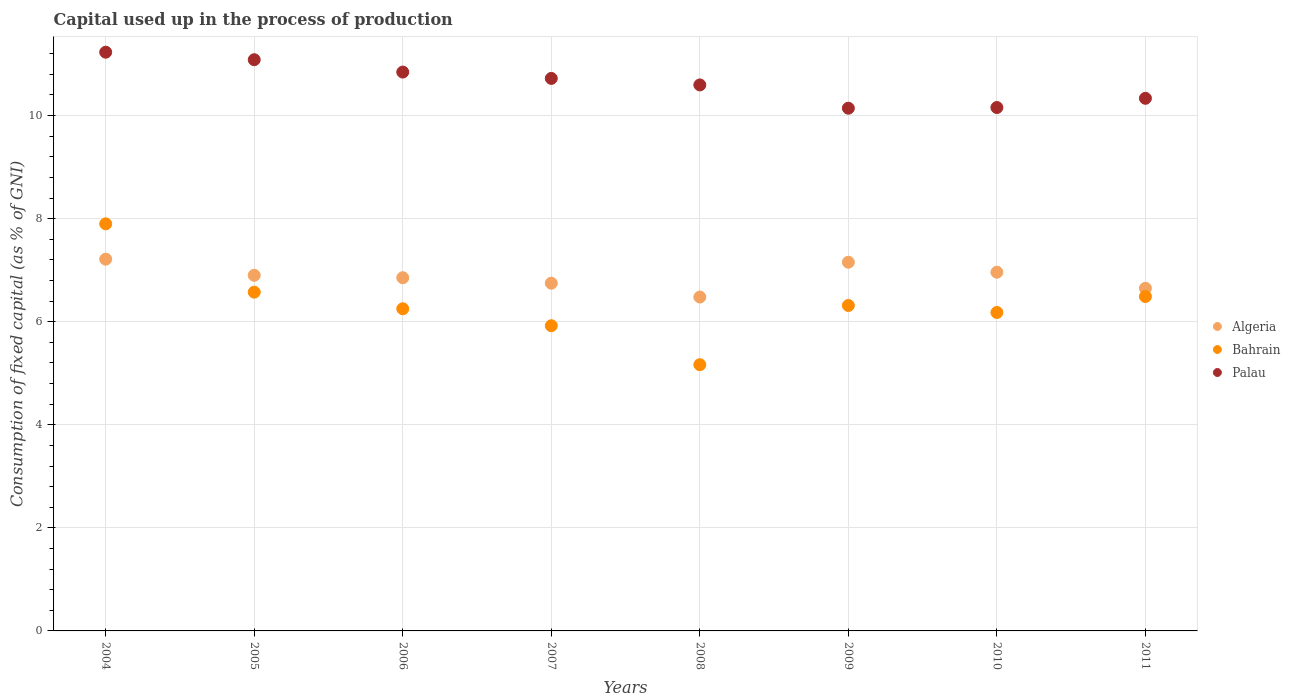What is the capital used up in the process of production in Algeria in 2007?
Give a very brief answer. 6.75. Across all years, what is the maximum capital used up in the process of production in Algeria?
Your answer should be compact. 7.21. Across all years, what is the minimum capital used up in the process of production in Algeria?
Your answer should be compact. 6.48. In which year was the capital used up in the process of production in Algeria minimum?
Provide a short and direct response. 2008. What is the total capital used up in the process of production in Palau in the graph?
Offer a very short reply. 85.11. What is the difference between the capital used up in the process of production in Algeria in 2004 and that in 2011?
Offer a very short reply. 0.56. What is the difference between the capital used up in the process of production in Palau in 2011 and the capital used up in the process of production in Bahrain in 2008?
Your answer should be compact. 5.17. What is the average capital used up in the process of production in Palau per year?
Keep it short and to the point. 10.64. In the year 2007, what is the difference between the capital used up in the process of production in Palau and capital used up in the process of production in Bahrain?
Offer a very short reply. 4.8. In how many years, is the capital used up in the process of production in Algeria greater than 6.8 %?
Provide a short and direct response. 5. What is the ratio of the capital used up in the process of production in Palau in 2006 to that in 2009?
Your answer should be compact. 1.07. Is the capital used up in the process of production in Algeria in 2008 less than that in 2011?
Offer a terse response. Yes. What is the difference between the highest and the second highest capital used up in the process of production in Palau?
Provide a short and direct response. 0.15. What is the difference between the highest and the lowest capital used up in the process of production in Palau?
Make the answer very short. 1.09. In how many years, is the capital used up in the process of production in Algeria greater than the average capital used up in the process of production in Algeria taken over all years?
Offer a terse response. 4. Is it the case that in every year, the sum of the capital used up in the process of production in Bahrain and capital used up in the process of production in Algeria  is greater than the capital used up in the process of production in Palau?
Your answer should be very brief. Yes. Does the capital used up in the process of production in Algeria monotonically increase over the years?
Provide a short and direct response. No. Is the capital used up in the process of production in Palau strictly greater than the capital used up in the process of production in Bahrain over the years?
Offer a terse response. Yes. What is the difference between two consecutive major ticks on the Y-axis?
Give a very brief answer. 2. Are the values on the major ticks of Y-axis written in scientific E-notation?
Offer a very short reply. No. Does the graph contain grids?
Provide a succinct answer. Yes. How many legend labels are there?
Make the answer very short. 3. How are the legend labels stacked?
Provide a succinct answer. Vertical. What is the title of the graph?
Offer a very short reply. Capital used up in the process of production. What is the label or title of the X-axis?
Your answer should be very brief. Years. What is the label or title of the Y-axis?
Make the answer very short. Consumption of fixed capital (as % of GNI). What is the Consumption of fixed capital (as % of GNI) in Algeria in 2004?
Give a very brief answer. 7.21. What is the Consumption of fixed capital (as % of GNI) in Bahrain in 2004?
Your answer should be compact. 7.9. What is the Consumption of fixed capital (as % of GNI) of Palau in 2004?
Ensure brevity in your answer.  11.23. What is the Consumption of fixed capital (as % of GNI) in Algeria in 2005?
Ensure brevity in your answer.  6.9. What is the Consumption of fixed capital (as % of GNI) of Bahrain in 2005?
Make the answer very short. 6.57. What is the Consumption of fixed capital (as % of GNI) in Palau in 2005?
Offer a terse response. 11.08. What is the Consumption of fixed capital (as % of GNI) of Algeria in 2006?
Offer a very short reply. 6.85. What is the Consumption of fixed capital (as % of GNI) in Bahrain in 2006?
Your answer should be very brief. 6.25. What is the Consumption of fixed capital (as % of GNI) of Palau in 2006?
Make the answer very short. 10.84. What is the Consumption of fixed capital (as % of GNI) in Algeria in 2007?
Your response must be concise. 6.75. What is the Consumption of fixed capital (as % of GNI) of Bahrain in 2007?
Offer a very short reply. 5.92. What is the Consumption of fixed capital (as % of GNI) of Palau in 2007?
Your answer should be compact. 10.72. What is the Consumption of fixed capital (as % of GNI) in Algeria in 2008?
Ensure brevity in your answer.  6.48. What is the Consumption of fixed capital (as % of GNI) in Bahrain in 2008?
Offer a terse response. 5.17. What is the Consumption of fixed capital (as % of GNI) in Palau in 2008?
Offer a terse response. 10.6. What is the Consumption of fixed capital (as % of GNI) of Algeria in 2009?
Make the answer very short. 7.15. What is the Consumption of fixed capital (as % of GNI) of Bahrain in 2009?
Give a very brief answer. 6.32. What is the Consumption of fixed capital (as % of GNI) in Palau in 2009?
Your answer should be very brief. 10.14. What is the Consumption of fixed capital (as % of GNI) of Algeria in 2010?
Your response must be concise. 6.96. What is the Consumption of fixed capital (as % of GNI) of Bahrain in 2010?
Your response must be concise. 6.18. What is the Consumption of fixed capital (as % of GNI) of Palau in 2010?
Your answer should be very brief. 10.16. What is the Consumption of fixed capital (as % of GNI) of Algeria in 2011?
Ensure brevity in your answer.  6.65. What is the Consumption of fixed capital (as % of GNI) in Bahrain in 2011?
Your response must be concise. 6.49. What is the Consumption of fixed capital (as % of GNI) of Palau in 2011?
Offer a terse response. 10.34. Across all years, what is the maximum Consumption of fixed capital (as % of GNI) in Algeria?
Your answer should be compact. 7.21. Across all years, what is the maximum Consumption of fixed capital (as % of GNI) in Bahrain?
Offer a very short reply. 7.9. Across all years, what is the maximum Consumption of fixed capital (as % of GNI) in Palau?
Give a very brief answer. 11.23. Across all years, what is the minimum Consumption of fixed capital (as % of GNI) of Algeria?
Ensure brevity in your answer.  6.48. Across all years, what is the minimum Consumption of fixed capital (as % of GNI) of Bahrain?
Your answer should be very brief. 5.17. Across all years, what is the minimum Consumption of fixed capital (as % of GNI) of Palau?
Your answer should be compact. 10.14. What is the total Consumption of fixed capital (as % of GNI) in Algeria in the graph?
Your response must be concise. 54.96. What is the total Consumption of fixed capital (as % of GNI) of Bahrain in the graph?
Your answer should be very brief. 50.8. What is the total Consumption of fixed capital (as % of GNI) in Palau in the graph?
Offer a terse response. 85.11. What is the difference between the Consumption of fixed capital (as % of GNI) of Algeria in 2004 and that in 2005?
Your answer should be compact. 0.31. What is the difference between the Consumption of fixed capital (as % of GNI) in Bahrain in 2004 and that in 2005?
Your answer should be compact. 1.33. What is the difference between the Consumption of fixed capital (as % of GNI) of Palau in 2004 and that in 2005?
Your answer should be very brief. 0.15. What is the difference between the Consumption of fixed capital (as % of GNI) in Algeria in 2004 and that in 2006?
Keep it short and to the point. 0.36. What is the difference between the Consumption of fixed capital (as % of GNI) of Bahrain in 2004 and that in 2006?
Offer a very short reply. 1.65. What is the difference between the Consumption of fixed capital (as % of GNI) in Palau in 2004 and that in 2006?
Provide a succinct answer. 0.39. What is the difference between the Consumption of fixed capital (as % of GNI) of Algeria in 2004 and that in 2007?
Ensure brevity in your answer.  0.47. What is the difference between the Consumption of fixed capital (as % of GNI) in Bahrain in 2004 and that in 2007?
Your response must be concise. 1.98. What is the difference between the Consumption of fixed capital (as % of GNI) in Palau in 2004 and that in 2007?
Make the answer very short. 0.51. What is the difference between the Consumption of fixed capital (as % of GNI) in Algeria in 2004 and that in 2008?
Ensure brevity in your answer.  0.73. What is the difference between the Consumption of fixed capital (as % of GNI) in Bahrain in 2004 and that in 2008?
Make the answer very short. 2.73. What is the difference between the Consumption of fixed capital (as % of GNI) in Palau in 2004 and that in 2008?
Ensure brevity in your answer.  0.64. What is the difference between the Consumption of fixed capital (as % of GNI) in Algeria in 2004 and that in 2009?
Make the answer very short. 0.06. What is the difference between the Consumption of fixed capital (as % of GNI) of Bahrain in 2004 and that in 2009?
Offer a terse response. 1.58. What is the difference between the Consumption of fixed capital (as % of GNI) in Palau in 2004 and that in 2009?
Your answer should be very brief. 1.09. What is the difference between the Consumption of fixed capital (as % of GNI) in Algeria in 2004 and that in 2010?
Make the answer very short. 0.25. What is the difference between the Consumption of fixed capital (as % of GNI) of Bahrain in 2004 and that in 2010?
Your answer should be very brief. 1.72. What is the difference between the Consumption of fixed capital (as % of GNI) of Palau in 2004 and that in 2010?
Keep it short and to the point. 1.07. What is the difference between the Consumption of fixed capital (as % of GNI) of Algeria in 2004 and that in 2011?
Your answer should be very brief. 0.56. What is the difference between the Consumption of fixed capital (as % of GNI) in Bahrain in 2004 and that in 2011?
Your answer should be very brief. 1.41. What is the difference between the Consumption of fixed capital (as % of GNI) in Palau in 2004 and that in 2011?
Your answer should be very brief. 0.89. What is the difference between the Consumption of fixed capital (as % of GNI) of Algeria in 2005 and that in 2006?
Provide a succinct answer. 0.05. What is the difference between the Consumption of fixed capital (as % of GNI) of Bahrain in 2005 and that in 2006?
Provide a short and direct response. 0.32. What is the difference between the Consumption of fixed capital (as % of GNI) in Palau in 2005 and that in 2006?
Offer a very short reply. 0.24. What is the difference between the Consumption of fixed capital (as % of GNI) in Algeria in 2005 and that in 2007?
Your answer should be very brief. 0.15. What is the difference between the Consumption of fixed capital (as % of GNI) in Bahrain in 2005 and that in 2007?
Ensure brevity in your answer.  0.65. What is the difference between the Consumption of fixed capital (as % of GNI) of Palau in 2005 and that in 2007?
Make the answer very short. 0.36. What is the difference between the Consumption of fixed capital (as % of GNI) of Algeria in 2005 and that in 2008?
Your answer should be compact. 0.42. What is the difference between the Consumption of fixed capital (as % of GNI) in Bahrain in 2005 and that in 2008?
Offer a very short reply. 1.41. What is the difference between the Consumption of fixed capital (as % of GNI) in Palau in 2005 and that in 2008?
Your answer should be compact. 0.49. What is the difference between the Consumption of fixed capital (as % of GNI) of Algeria in 2005 and that in 2009?
Offer a terse response. -0.25. What is the difference between the Consumption of fixed capital (as % of GNI) of Bahrain in 2005 and that in 2009?
Your answer should be very brief. 0.26. What is the difference between the Consumption of fixed capital (as % of GNI) of Palau in 2005 and that in 2009?
Offer a terse response. 0.94. What is the difference between the Consumption of fixed capital (as % of GNI) of Algeria in 2005 and that in 2010?
Offer a very short reply. -0.06. What is the difference between the Consumption of fixed capital (as % of GNI) in Bahrain in 2005 and that in 2010?
Provide a short and direct response. 0.39. What is the difference between the Consumption of fixed capital (as % of GNI) of Palau in 2005 and that in 2010?
Ensure brevity in your answer.  0.93. What is the difference between the Consumption of fixed capital (as % of GNI) in Algeria in 2005 and that in 2011?
Provide a succinct answer. 0.25. What is the difference between the Consumption of fixed capital (as % of GNI) in Bahrain in 2005 and that in 2011?
Your answer should be compact. 0.08. What is the difference between the Consumption of fixed capital (as % of GNI) of Palau in 2005 and that in 2011?
Your answer should be very brief. 0.75. What is the difference between the Consumption of fixed capital (as % of GNI) of Algeria in 2006 and that in 2007?
Keep it short and to the point. 0.11. What is the difference between the Consumption of fixed capital (as % of GNI) of Bahrain in 2006 and that in 2007?
Your answer should be compact. 0.33. What is the difference between the Consumption of fixed capital (as % of GNI) in Palau in 2006 and that in 2007?
Ensure brevity in your answer.  0.12. What is the difference between the Consumption of fixed capital (as % of GNI) in Algeria in 2006 and that in 2008?
Your answer should be compact. 0.37. What is the difference between the Consumption of fixed capital (as % of GNI) in Bahrain in 2006 and that in 2008?
Offer a very short reply. 1.09. What is the difference between the Consumption of fixed capital (as % of GNI) in Palau in 2006 and that in 2008?
Your response must be concise. 0.25. What is the difference between the Consumption of fixed capital (as % of GNI) of Algeria in 2006 and that in 2009?
Ensure brevity in your answer.  -0.3. What is the difference between the Consumption of fixed capital (as % of GNI) in Bahrain in 2006 and that in 2009?
Your answer should be compact. -0.06. What is the difference between the Consumption of fixed capital (as % of GNI) in Palau in 2006 and that in 2009?
Provide a short and direct response. 0.7. What is the difference between the Consumption of fixed capital (as % of GNI) of Algeria in 2006 and that in 2010?
Provide a succinct answer. -0.11. What is the difference between the Consumption of fixed capital (as % of GNI) in Bahrain in 2006 and that in 2010?
Keep it short and to the point. 0.07. What is the difference between the Consumption of fixed capital (as % of GNI) of Palau in 2006 and that in 2010?
Your response must be concise. 0.69. What is the difference between the Consumption of fixed capital (as % of GNI) in Algeria in 2006 and that in 2011?
Provide a short and direct response. 0.2. What is the difference between the Consumption of fixed capital (as % of GNI) in Bahrain in 2006 and that in 2011?
Provide a succinct answer. -0.24. What is the difference between the Consumption of fixed capital (as % of GNI) in Palau in 2006 and that in 2011?
Give a very brief answer. 0.51. What is the difference between the Consumption of fixed capital (as % of GNI) of Algeria in 2007 and that in 2008?
Offer a very short reply. 0.27. What is the difference between the Consumption of fixed capital (as % of GNI) in Bahrain in 2007 and that in 2008?
Make the answer very short. 0.76. What is the difference between the Consumption of fixed capital (as % of GNI) of Palau in 2007 and that in 2008?
Your response must be concise. 0.13. What is the difference between the Consumption of fixed capital (as % of GNI) of Algeria in 2007 and that in 2009?
Provide a succinct answer. -0.41. What is the difference between the Consumption of fixed capital (as % of GNI) in Bahrain in 2007 and that in 2009?
Your answer should be very brief. -0.39. What is the difference between the Consumption of fixed capital (as % of GNI) of Palau in 2007 and that in 2009?
Your response must be concise. 0.58. What is the difference between the Consumption of fixed capital (as % of GNI) of Algeria in 2007 and that in 2010?
Your answer should be very brief. -0.21. What is the difference between the Consumption of fixed capital (as % of GNI) of Bahrain in 2007 and that in 2010?
Your answer should be compact. -0.26. What is the difference between the Consumption of fixed capital (as % of GNI) of Palau in 2007 and that in 2010?
Keep it short and to the point. 0.56. What is the difference between the Consumption of fixed capital (as % of GNI) of Algeria in 2007 and that in 2011?
Offer a terse response. 0.1. What is the difference between the Consumption of fixed capital (as % of GNI) in Bahrain in 2007 and that in 2011?
Your answer should be very brief. -0.57. What is the difference between the Consumption of fixed capital (as % of GNI) in Palau in 2007 and that in 2011?
Provide a short and direct response. 0.39. What is the difference between the Consumption of fixed capital (as % of GNI) of Algeria in 2008 and that in 2009?
Your answer should be very brief. -0.68. What is the difference between the Consumption of fixed capital (as % of GNI) in Bahrain in 2008 and that in 2009?
Give a very brief answer. -1.15. What is the difference between the Consumption of fixed capital (as % of GNI) in Palau in 2008 and that in 2009?
Your answer should be compact. 0.45. What is the difference between the Consumption of fixed capital (as % of GNI) in Algeria in 2008 and that in 2010?
Make the answer very short. -0.48. What is the difference between the Consumption of fixed capital (as % of GNI) of Bahrain in 2008 and that in 2010?
Your answer should be compact. -1.01. What is the difference between the Consumption of fixed capital (as % of GNI) in Palau in 2008 and that in 2010?
Your answer should be compact. 0.44. What is the difference between the Consumption of fixed capital (as % of GNI) of Algeria in 2008 and that in 2011?
Offer a very short reply. -0.17. What is the difference between the Consumption of fixed capital (as % of GNI) in Bahrain in 2008 and that in 2011?
Your response must be concise. -1.32. What is the difference between the Consumption of fixed capital (as % of GNI) in Palau in 2008 and that in 2011?
Your response must be concise. 0.26. What is the difference between the Consumption of fixed capital (as % of GNI) in Algeria in 2009 and that in 2010?
Your response must be concise. 0.19. What is the difference between the Consumption of fixed capital (as % of GNI) of Bahrain in 2009 and that in 2010?
Ensure brevity in your answer.  0.14. What is the difference between the Consumption of fixed capital (as % of GNI) in Palau in 2009 and that in 2010?
Keep it short and to the point. -0.01. What is the difference between the Consumption of fixed capital (as % of GNI) of Algeria in 2009 and that in 2011?
Provide a succinct answer. 0.51. What is the difference between the Consumption of fixed capital (as % of GNI) in Bahrain in 2009 and that in 2011?
Provide a short and direct response. -0.17. What is the difference between the Consumption of fixed capital (as % of GNI) of Palau in 2009 and that in 2011?
Make the answer very short. -0.19. What is the difference between the Consumption of fixed capital (as % of GNI) in Algeria in 2010 and that in 2011?
Your answer should be compact. 0.31. What is the difference between the Consumption of fixed capital (as % of GNI) in Bahrain in 2010 and that in 2011?
Keep it short and to the point. -0.31. What is the difference between the Consumption of fixed capital (as % of GNI) in Palau in 2010 and that in 2011?
Provide a succinct answer. -0.18. What is the difference between the Consumption of fixed capital (as % of GNI) in Algeria in 2004 and the Consumption of fixed capital (as % of GNI) in Bahrain in 2005?
Your answer should be compact. 0.64. What is the difference between the Consumption of fixed capital (as % of GNI) of Algeria in 2004 and the Consumption of fixed capital (as % of GNI) of Palau in 2005?
Offer a terse response. -3.87. What is the difference between the Consumption of fixed capital (as % of GNI) in Bahrain in 2004 and the Consumption of fixed capital (as % of GNI) in Palau in 2005?
Your answer should be very brief. -3.18. What is the difference between the Consumption of fixed capital (as % of GNI) in Algeria in 2004 and the Consumption of fixed capital (as % of GNI) in Bahrain in 2006?
Keep it short and to the point. 0.96. What is the difference between the Consumption of fixed capital (as % of GNI) of Algeria in 2004 and the Consumption of fixed capital (as % of GNI) of Palau in 2006?
Your answer should be very brief. -3.63. What is the difference between the Consumption of fixed capital (as % of GNI) in Bahrain in 2004 and the Consumption of fixed capital (as % of GNI) in Palau in 2006?
Provide a succinct answer. -2.94. What is the difference between the Consumption of fixed capital (as % of GNI) of Algeria in 2004 and the Consumption of fixed capital (as % of GNI) of Bahrain in 2007?
Give a very brief answer. 1.29. What is the difference between the Consumption of fixed capital (as % of GNI) of Algeria in 2004 and the Consumption of fixed capital (as % of GNI) of Palau in 2007?
Your answer should be very brief. -3.51. What is the difference between the Consumption of fixed capital (as % of GNI) of Bahrain in 2004 and the Consumption of fixed capital (as % of GNI) of Palau in 2007?
Provide a short and direct response. -2.82. What is the difference between the Consumption of fixed capital (as % of GNI) of Algeria in 2004 and the Consumption of fixed capital (as % of GNI) of Bahrain in 2008?
Keep it short and to the point. 2.05. What is the difference between the Consumption of fixed capital (as % of GNI) in Algeria in 2004 and the Consumption of fixed capital (as % of GNI) in Palau in 2008?
Provide a succinct answer. -3.38. What is the difference between the Consumption of fixed capital (as % of GNI) in Bahrain in 2004 and the Consumption of fixed capital (as % of GNI) in Palau in 2008?
Give a very brief answer. -2.7. What is the difference between the Consumption of fixed capital (as % of GNI) of Algeria in 2004 and the Consumption of fixed capital (as % of GNI) of Bahrain in 2009?
Offer a terse response. 0.9. What is the difference between the Consumption of fixed capital (as % of GNI) in Algeria in 2004 and the Consumption of fixed capital (as % of GNI) in Palau in 2009?
Offer a very short reply. -2.93. What is the difference between the Consumption of fixed capital (as % of GNI) in Bahrain in 2004 and the Consumption of fixed capital (as % of GNI) in Palau in 2009?
Keep it short and to the point. -2.24. What is the difference between the Consumption of fixed capital (as % of GNI) in Algeria in 2004 and the Consumption of fixed capital (as % of GNI) in Bahrain in 2010?
Provide a short and direct response. 1.03. What is the difference between the Consumption of fixed capital (as % of GNI) in Algeria in 2004 and the Consumption of fixed capital (as % of GNI) in Palau in 2010?
Ensure brevity in your answer.  -2.94. What is the difference between the Consumption of fixed capital (as % of GNI) in Bahrain in 2004 and the Consumption of fixed capital (as % of GNI) in Palau in 2010?
Keep it short and to the point. -2.26. What is the difference between the Consumption of fixed capital (as % of GNI) of Algeria in 2004 and the Consumption of fixed capital (as % of GNI) of Bahrain in 2011?
Your answer should be very brief. 0.72. What is the difference between the Consumption of fixed capital (as % of GNI) in Algeria in 2004 and the Consumption of fixed capital (as % of GNI) in Palau in 2011?
Ensure brevity in your answer.  -3.12. What is the difference between the Consumption of fixed capital (as % of GNI) of Bahrain in 2004 and the Consumption of fixed capital (as % of GNI) of Palau in 2011?
Make the answer very short. -2.44. What is the difference between the Consumption of fixed capital (as % of GNI) of Algeria in 2005 and the Consumption of fixed capital (as % of GNI) of Bahrain in 2006?
Provide a short and direct response. 0.65. What is the difference between the Consumption of fixed capital (as % of GNI) of Algeria in 2005 and the Consumption of fixed capital (as % of GNI) of Palau in 2006?
Offer a very short reply. -3.94. What is the difference between the Consumption of fixed capital (as % of GNI) in Bahrain in 2005 and the Consumption of fixed capital (as % of GNI) in Palau in 2006?
Provide a short and direct response. -4.27. What is the difference between the Consumption of fixed capital (as % of GNI) of Algeria in 2005 and the Consumption of fixed capital (as % of GNI) of Bahrain in 2007?
Your response must be concise. 0.98. What is the difference between the Consumption of fixed capital (as % of GNI) in Algeria in 2005 and the Consumption of fixed capital (as % of GNI) in Palau in 2007?
Provide a succinct answer. -3.82. What is the difference between the Consumption of fixed capital (as % of GNI) of Bahrain in 2005 and the Consumption of fixed capital (as % of GNI) of Palau in 2007?
Your answer should be compact. -4.15. What is the difference between the Consumption of fixed capital (as % of GNI) in Algeria in 2005 and the Consumption of fixed capital (as % of GNI) in Bahrain in 2008?
Offer a very short reply. 1.73. What is the difference between the Consumption of fixed capital (as % of GNI) of Algeria in 2005 and the Consumption of fixed capital (as % of GNI) of Palau in 2008?
Offer a very short reply. -3.69. What is the difference between the Consumption of fixed capital (as % of GNI) in Bahrain in 2005 and the Consumption of fixed capital (as % of GNI) in Palau in 2008?
Ensure brevity in your answer.  -4.02. What is the difference between the Consumption of fixed capital (as % of GNI) of Algeria in 2005 and the Consumption of fixed capital (as % of GNI) of Bahrain in 2009?
Your response must be concise. 0.59. What is the difference between the Consumption of fixed capital (as % of GNI) in Algeria in 2005 and the Consumption of fixed capital (as % of GNI) in Palau in 2009?
Provide a short and direct response. -3.24. What is the difference between the Consumption of fixed capital (as % of GNI) in Bahrain in 2005 and the Consumption of fixed capital (as % of GNI) in Palau in 2009?
Provide a short and direct response. -3.57. What is the difference between the Consumption of fixed capital (as % of GNI) of Algeria in 2005 and the Consumption of fixed capital (as % of GNI) of Bahrain in 2010?
Offer a very short reply. 0.72. What is the difference between the Consumption of fixed capital (as % of GNI) in Algeria in 2005 and the Consumption of fixed capital (as % of GNI) in Palau in 2010?
Your answer should be very brief. -3.26. What is the difference between the Consumption of fixed capital (as % of GNI) in Bahrain in 2005 and the Consumption of fixed capital (as % of GNI) in Palau in 2010?
Provide a succinct answer. -3.58. What is the difference between the Consumption of fixed capital (as % of GNI) in Algeria in 2005 and the Consumption of fixed capital (as % of GNI) in Bahrain in 2011?
Give a very brief answer. 0.41. What is the difference between the Consumption of fixed capital (as % of GNI) in Algeria in 2005 and the Consumption of fixed capital (as % of GNI) in Palau in 2011?
Your answer should be very brief. -3.43. What is the difference between the Consumption of fixed capital (as % of GNI) in Bahrain in 2005 and the Consumption of fixed capital (as % of GNI) in Palau in 2011?
Provide a succinct answer. -3.76. What is the difference between the Consumption of fixed capital (as % of GNI) of Algeria in 2006 and the Consumption of fixed capital (as % of GNI) of Bahrain in 2007?
Keep it short and to the point. 0.93. What is the difference between the Consumption of fixed capital (as % of GNI) of Algeria in 2006 and the Consumption of fixed capital (as % of GNI) of Palau in 2007?
Provide a succinct answer. -3.87. What is the difference between the Consumption of fixed capital (as % of GNI) in Bahrain in 2006 and the Consumption of fixed capital (as % of GNI) in Palau in 2007?
Provide a short and direct response. -4.47. What is the difference between the Consumption of fixed capital (as % of GNI) of Algeria in 2006 and the Consumption of fixed capital (as % of GNI) of Bahrain in 2008?
Provide a succinct answer. 1.69. What is the difference between the Consumption of fixed capital (as % of GNI) of Algeria in 2006 and the Consumption of fixed capital (as % of GNI) of Palau in 2008?
Make the answer very short. -3.74. What is the difference between the Consumption of fixed capital (as % of GNI) in Bahrain in 2006 and the Consumption of fixed capital (as % of GNI) in Palau in 2008?
Offer a terse response. -4.34. What is the difference between the Consumption of fixed capital (as % of GNI) of Algeria in 2006 and the Consumption of fixed capital (as % of GNI) of Bahrain in 2009?
Offer a terse response. 0.54. What is the difference between the Consumption of fixed capital (as % of GNI) of Algeria in 2006 and the Consumption of fixed capital (as % of GNI) of Palau in 2009?
Offer a terse response. -3.29. What is the difference between the Consumption of fixed capital (as % of GNI) in Bahrain in 2006 and the Consumption of fixed capital (as % of GNI) in Palau in 2009?
Give a very brief answer. -3.89. What is the difference between the Consumption of fixed capital (as % of GNI) of Algeria in 2006 and the Consumption of fixed capital (as % of GNI) of Bahrain in 2010?
Make the answer very short. 0.67. What is the difference between the Consumption of fixed capital (as % of GNI) in Algeria in 2006 and the Consumption of fixed capital (as % of GNI) in Palau in 2010?
Keep it short and to the point. -3.3. What is the difference between the Consumption of fixed capital (as % of GNI) in Bahrain in 2006 and the Consumption of fixed capital (as % of GNI) in Palau in 2010?
Provide a succinct answer. -3.91. What is the difference between the Consumption of fixed capital (as % of GNI) of Algeria in 2006 and the Consumption of fixed capital (as % of GNI) of Bahrain in 2011?
Your answer should be very brief. 0.36. What is the difference between the Consumption of fixed capital (as % of GNI) of Algeria in 2006 and the Consumption of fixed capital (as % of GNI) of Palau in 2011?
Give a very brief answer. -3.48. What is the difference between the Consumption of fixed capital (as % of GNI) in Bahrain in 2006 and the Consumption of fixed capital (as % of GNI) in Palau in 2011?
Provide a short and direct response. -4.08. What is the difference between the Consumption of fixed capital (as % of GNI) in Algeria in 2007 and the Consumption of fixed capital (as % of GNI) in Bahrain in 2008?
Ensure brevity in your answer.  1.58. What is the difference between the Consumption of fixed capital (as % of GNI) in Algeria in 2007 and the Consumption of fixed capital (as % of GNI) in Palau in 2008?
Offer a very short reply. -3.85. What is the difference between the Consumption of fixed capital (as % of GNI) of Bahrain in 2007 and the Consumption of fixed capital (as % of GNI) of Palau in 2008?
Provide a short and direct response. -4.67. What is the difference between the Consumption of fixed capital (as % of GNI) of Algeria in 2007 and the Consumption of fixed capital (as % of GNI) of Bahrain in 2009?
Give a very brief answer. 0.43. What is the difference between the Consumption of fixed capital (as % of GNI) in Algeria in 2007 and the Consumption of fixed capital (as % of GNI) in Palau in 2009?
Give a very brief answer. -3.4. What is the difference between the Consumption of fixed capital (as % of GNI) of Bahrain in 2007 and the Consumption of fixed capital (as % of GNI) of Palau in 2009?
Keep it short and to the point. -4.22. What is the difference between the Consumption of fixed capital (as % of GNI) in Algeria in 2007 and the Consumption of fixed capital (as % of GNI) in Bahrain in 2010?
Your answer should be compact. 0.57. What is the difference between the Consumption of fixed capital (as % of GNI) in Algeria in 2007 and the Consumption of fixed capital (as % of GNI) in Palau in 2010?
Your answer should be compact. -3.41. What is the difference between the Consumption of fixed capital (as % of GNI) in Bahrain in 2007 and the Consumption of fixed capital (as % of GNI) in Palau in 2010?
Your response must be concise. -4.23. What is the difference between the Consumption of fixed capital (as % of GNI) in Algeria in 2007 and the Consumption of fixed capital (as % of GNI) in Bahrain in 2011?
Offer a very short reply. 0.26. What is the difference between the Consumption of fixed capital (as % of GNI) in Algeria in 2007 and the Consumption of fixed capital (as % of GNI) in Palau in 2011?
Keep it short and to the point. -3.59. What is the difference between the Consumption of fixed capital (as % of GNI) of Bahrain in 2007 and the Consumption of fixed capital (as % of GNI) of Palau in 2011?
Keep it short and to the point. -4.41. What is the difference between the Consumption of fixed capital (as % of GNI) of Algeria in 2008 and the Consumption of fixed capital (as % of GNI) of Bahrain in 2009?
Ensure brevity in your answer.  0.16. What is the difference between the Consumption of fixed capital (as % of GNI) in Algeria in 2008 and the Consumption of fixed capital (as % of GNI) in Palau in 2009?
Make the answer very short. -3.66. What is the difference between the Consumption of fixed capital (as % of GNI) in Bahrain in 2008 and the Consumption of fixed capital (as % of GNI) in Palau in 2009?
Provide a succinct answer. -4.98. What is the difference between the Consumption of fixed capital (as % of GNI) in Algeria in 2008 and the Consumption of fixed capital (as % of GNI) in Bahrain in 2010?
Ensure brevity in your answer.  0.3. What is the difference between the Consumption of fixed capital (as % of GNI) of Algeria in 2008 and the Consumption of fixed capital (as % of GNI) of Palau in 2010?
Provide a succinct answer. -3.68. What is the difference between the Consumption of fixed capital (as % of GNI) in Bahrain in 2008 and the Consumption of fixed capital (as % of GNI) in Palau in 2010?
Offer a terse response. -4.99. What is the difference between the Consumption of fixed capital (as % of GNI) of Algeria in 2008 and the Consumption of fixed capital (as % of GNI) of Bahrain in 2011?
Make the answer very short. -0.01. What is the difference between the Consumption of fixed capital (as % of GNI) in Algeria in 2008 and the Consumption of fixed capital (as % of GNI) in Palau in 2011?
Your answer should be compact. -3.86. What is the difference between the Consumption of fixed capital (as % of GNI) of Bahrain in 2008 and the Consumption of fixed capital (as % of GNI) of Palau in 2011?
Offer a very short reply. -5.17. What is the difference between the Consumption of fixed capital (as % of GNI) in Algeria in 2009 and the Consumption of fixed capital (as % of GNI) in Bahrain in 2010?
Offer a terse response. 0.98. What is the difference between the Consumption of fixed capital (as % of GNI) in Algeria in 2009 and the Consumption of fixed capital (as % of GNI) in Palau in 2010?
Your response must be concise. -3. What is the difference between the Consumption of fixed capital (as % of GNI) in Bahrain in 2009 and the Consumption of fixed capital (as % of GNI) in Palau in 2010?
Offer a very short reply. -3.84. What is the difference between the Consumption of fixed capital (as % of GNI) of Algeria in 2009 and the Consumption of fixed capital (as % of GNI) of Bahrain in 2011?
Your response must be concise. 0.67. What is the difference between the Consumption of fixed capital (as % of GNI) in Algeria in 2009 and the Consumption of fixed capital (as % of GNI) in Palau in 2011?
Your answer should be very brief. -3.18. What is the difference between the Consumption of fixed capital (as % of GNI) of Bahrain in 2009 and the Consumption of fixed capital (as % of GNI) of Palau in 2011?
Offer a terse response. -4.02. What is the difference between the Consumption of fixed capital (as % of GNI) of Algeria in 2010 and the Consumption of fixed capital (as % of GNI) of Bahrain in 2011?
Ensure brevity in your answer.  0.47. What is the difference between the Consumption of fixed capital (as % of GNI) of Algeria in 2010 and the Consumption of fixed capital (as % of GNI) of Palau in 2011?
Provide a short and direct response. -3.37. What is the difference between the Consumption of fixed capital (as % of GNI) of Bahrain in 2010 and the Consumption of fixed capital (as % of GNI) of Palau in 2011?
Keep it short and to the point. -4.16. What is the average Consumption of fixed capital (as % of GNI) of Algeria per year?
Your response must be concise. 6.87. What is the average Consumption of fixed capital (as % of GNI) in Bahrain per year?
Ensure brevity in your answer.  6.35. What is the average Consumption of fixed capital (as % of GNI) of Palau per year?
Provide a succinct answer. 10.64. In the year 2004, what is the difference between the Consumption of fixed capital (as % of GNI) of Algeria and Consumption of fixed capital (as % of GNI) of Bahrain?
Provide a short and direct response. -0.69. In the year 2004, what is the difference between the Consumption of fixed capital (as % of GNI) of Algeria and Consumption of fixed capital (as % of GNI) of Palau?
Make the answer very short. -4.02. In the year 2004, what is the difference between the Consumption of fixed capital (as % of GNI) of Bahrain and Consumption of fixed capital (as % of GNI) of Palau?
Give a very brief answer. -3.33. In the year 2005, what is the difference between the Consumption of fixed capital (as % of GNI) of Algeria and Consumption of fixed capital (as % of GNI) of Bahrain?
Ensure brevity in your answer.  0.33. In the year 2005, what is the difference between the Consumption of fixed capital (as % of GNI) in Algeria and Consumption of fixed capital (as % of GNI) in Palau?
Ensure brevity in your answer.  -4.18. In the year 2005, what is the difference between the Consumption of fixed capital (as % of GNI) of Bahrain and Consumption of fixed capital (as % of GNI) of Palau?
Offer a very short reply. -4.51. In the year 2006, what is the difference between the Consumption of fixed capital (as % of GNI) in Algeria and Consumption of fixed capital (as % of GNI) in Bahrain?
Provide a succinct answer. 0.6. In the year 2006, what is the difference between the Consumption of fixed capital (as % of GNI) in Algeria and Consumption of fixed capital (as % of GNI) in Palau?
Ensure brevity in your answer.  -3.99. In the year 2006, what is the difference between the Consumption of fixed capital (as % of GNI) of Bahrain and Consumption of fixed capital (as % of GNI) of Palau?
Provide a short and direct response. -4.59. In the year 2007, what is the difference between the Consumption of fixed capital (as % of GNI) in Algeria and Consumption of fixed capital (as % of GNI) in Bahrain?
Give a very brief answer. 0.82. In the year 2007, what is the difference between the Consumption of fixed capital (as % of GNI) in Algeria and Consumption of fixed capital (as % of GNI) in Palau?
Your answer should be very brief. -3.97. In the year 2007, what is the difference between the Consumption of fixed capital (as % of GNI) of Bahrain and Consumption of fixed capital (as % of GNI) of Palau?
Make the answer very short. -4.8. In the year 2008, what is the difference between the Consumption of fixed capital (as % of GNI) of Algeria and Consumption of fixed capital (as % of GNI) of Bahrain?
Offer a very short reply. 1.31. In the year 2008, what is the difference between the Consumption of fixed capital (as % of GNI) in Algeria and Consumption of fixed capital (as % of GNI) in Palau?
Your answer should be very brief. -4.12. In the year 2008, what is the difference between the Consumption of fixed capital (as % of GNI) of Bahrain and Consumption of fixed capital (as % of GNI) of Palau?
Provide a succinct answer. -5.43. In the year 2009, what is the difference between the Consumption of fixed capital (as % of GNI) in Algeria and Consumption of fixed capital (as % of GNI) in Bahrain?
Offer a terse response. 0.84. In the year 2009, what is the difference between the Consumption of fixed capital (as % of GNI) in Algeria and Consumption of fixed capital (as % of GNI) in Palau?
Provide a succinct answer. -2.99. In the year 2009, what is the difference between the Consumption of fixed capital (as % of GNI) in Bahrain and Consumption of fixed capital (as % of GNI) in Palau?
Make the answer very short. -3.83. In the year 2010, what is the difference between the Consumption of fixed capital (as % of GNI) of Algeria and Consumption of fixed capital (as % of GNI) of Bahrain?
Provide a succinct answer. 0.78. In the year 2010, what is the difference between the Consumption of fixed capital (as % of GNI) of Algeria and Consumption of fixed capital (as % of GNI) of Palau?
Your answer should be compact. -3.2. In the year 2010, what is the difference between the Consumption of fixed capital (as % of GNI) of Bahrain and Consumption of fixed capital (as % of GNI) of Palau?
Make the answer very short. -3.98. In the year 2011, what is the difference between the Consumption of fixed capital (as % of GNI) in Algeria and Consumption of fixed capital (as % of GNI) in Bahrain?
Offer a terse response. 0.16. In the year 2011, what is the difference between the Consumption of fixed capital (as % of GNI) in Algeria and Consumption of fixed capital (as % of GNI) in Palau?
Offer a very short reply. -3.69. In the year 2011, what is the difference between the Consumption of fixed capital (as % of GNI) of Bahrain and Consumption of fixed capital (as % of GNI) of Palau?
Your answer should be very brief. -3.85. What is the ratio of the Consumption of fixed capital (as % of GNI) of Algeria in 2004 to that in 2005?
Ensure brevity in your answer.  1.05. What is the ratio of the Consumption of fixed capital (as % of GNI) in Bahrain in 2004 to that in 2005?
Provide a succinct answer. 1.2. What is the ratio of the Consumption of fixed capital (as % of GNI) in Palau in 2004 to that in 2005?
Provide a short and direct response. 1.01. What is the ratio of the Consumption of fixed capital (as % of GNI) in Algeria in 2004 to that in 2006?
Your response must be concise. 1.05. What is the ratio of the Consumption of fixed capital (as % of GNI) of Bahrain in 2004 to that in 2006?
Ensure brevity in your answer.  1.26. What is the ratio of the Consumption of fixed capital (as % of GNI) in Palau in 2004 to that in 2006?
Your answer should be very brief. 1.04. What is the ratio of the Consumption of fixed capital (as % of GNI) of Algeria in 2004 to that in 2007?
Give a very brief answer. 1.07. What is the ratio of the Consumption of fixed capital (as % of GNI) in Bahrain in 2004 to that in 2007?
Your answer should be compact. 1.33. What is the ratio of the Consumption of fixed capital (as % of GNI) in Palau in 2004 to that in 2007?
Offer a terse response. 1.05. What is the ratio of the Consumption of fixed capital (as % of GNI) in Algeria in 2004 to that in 2008?
Your answer should be compact. 1.11. What is the ratio of the Consumption of fixed capital (as % of GNI) of Bahrain in 2004 to that in 2008?
Your response must be concise. 1.53. What is the ratio of the Consumption of fixed capital (as % of GNI) in Palau in 2004 to that in 2008?
Provide a succinct answer. 1.06. What is the ratio of the Consumption of fixed capital (as % of GNI) in Algeria in 2004 to that in 2009?
Ensure brevity in your answer.  1.01. What is the ratio of the Consumption of fixed capital (as % of GNI) of Bahrain in 2004 to that in 2009?
Ensure brevity in your answer.  1.25. What is the ratio of the Consumption of fixed capital (as % of GNI) of Palau in 2004 to that in 2009?
Ensure brevity in your answer.  1.11. What is the ratio of the Consumption of fixed capital (as % of GNI) in Algeria in 2004 to that in 2010?
Give a very brief answer. 1.04. What is the ratio of the Consumption of fixed capital (as % of GNI) of Bahrain in 2004 to that in 2010?
Offer a very short reply. 1.28. What is the ratio of the Consumption of fixed capital (as % of GNI) in Palau in 2004 to that in 2010?
Make the answer very short. 1.11. What is the ratio of the Consumption of fixed capital (as % of GNI) of Algeria in 2004 to that in 2011?
Make the answer very short. 1.08. What is the ratio of the Consumption of fixed capital (as % of GNI) in Bahrain in 2004 to that in 2011?
Offer a terse response. 1.22. What is the ratio of the Consumption of fixed capital (as % of GNI) of Palau in 2004 to that in 2011?
Your response must be concise. 1.09. What is the ratio of the Consumption of fixed capital (as % of GNI) of Algeria in 2005 to that in 2006?
Make the answer very short. 1.01. What is the ratio of the Consumption of fixed capital (as % of GNI) in Bahrain in 2005 to that in 2006?
Provide a succinct answer. 1.05. What is the ratio of the Consumption of fixed capital (as % of GNI) of Palau in 2005 to that in 2006?
Offer a very short reply. 1.02. What is the ratio of the Consumption of fixed capital (as % of GNI) of Algeria in 2005 to that in 2007?
Provide a short and direct response. 1.02. What is the ratio of the Consumption of fixed capital (as % of GNI) of Bahrain in 2005 to that in 2007?
Provide a short and direct response. 1.11. What is the ratio of the Consumption of fixed capital (as % of GNI) of Palau in 2005 to that in 2007?
Offer a terse response. 1.03. What is the ratio of the Consumption of fixed capital (as % of GNI) in Algeria in 2005 to that in 2008?
Give a very brief answer. 1.07. What is the ratio of the Consumption of fixed capital (as % of GNI) of Bahrain in 2005 to that in 2008?
Keep it short and to the point. 1.27. What is the ratio of the Consumption of fixed capital (as % of GNI) in Palau in 2005 to that in 2008?
Ensure brevity in your answer.  1.05. What is the ratio of the Consumption of fixed capital (as % of GNI) in Algeria in 2005 to that in 2009?
Provide a short and direct response. 0.96. What is the ratio of the Consumption of fixed capital (as % of GNI) in Bahrain in 2005 to that in 2009?
Offer a very short reply. 1.04. What is the ratio of the Consumption of fixed capital (as % of GNI) of Palau in 2005 to that in 2009?
Provide a succinct answer. 1.09. What is the ratio of the Consumption of fixed capital (as % of GNI) of Bahrain in 2005 to that in 2010?
Your answer should be compact. 1.06. What is the ratio of the Consumption of fixed capital (as % of GNI) of Palau in 2005 to that in 2010?
Your answer should be compact. 1.09. What is the ratio of the Consumption of fixed capital (as % of GNI) of Algeria in 2005 to that in 2011?
Provide a short and direct response. 1.04. What is the ratio of the Consumption of fixed capital (as % of GNI) of Palau in 2005 to that in 2011?
Your response must be concise. 1.07. What is the ratio of the Consumption of fixed capital (as % of GNI) in Algeria in 2006 to that in 2007?
Make the answer very short. 1.02. What is the ratio of the Consumption of fixed capital (as % of GNI) of Bahrain in 2006 to that in 2007?
Your answer should be very brief. 1.06. What is the ratio of the Consumption of fixed capital (as % of GNI) in Palau in 2006 to that in 2007?
Provide a short and direct response. 1.01. What is the ratio of the Consumption of fixed capital (as % of GNI) of Algeria in 2006 to that in 2008?
Offer a terse response. 1.06. What is the ratio of the Consumption of fixed capital (as % of GNI) in Bahrain in 2006 to that in 2008?
Give a very brief answer. 1.21. What is the ratio of the Consumption of fixed capital (as % of GNI) in Palau in 2006 to that in 2008?
Your answer should be very brief. 1.02. What is the ratio of the Consumption of fixed capital (as % of GNI) in Algeria in 2006 to that in 2009?
Your answer should be compact. 0.96. What is the ratio of the Consumption of fixed capital (as % of GNI) in Bahrain in 2006 to that in 2009?
Keep it short and to the point. 0.99. What is the ratio of the Consumption of fixed capital (as % of GNI) in Palau in 2006 to that in 2009?
Your response must be concise. 1.07. What is the ratio of the Consumption of fixed capital (as % of GNI) of Algeria in 2006 to that in 2010?
Make the answer very short. 0.98. What is the ratio of the Consumption of fixed capital (as % of GNI) of Bahrain in 2006 to that in 2010?
Provide a short and direct response. 1.01. What is the ratio of the Consumption of fixed capital (as % of GNI) in Palau in 2006 to that in 2010?
Ensure brevity in your answer.  1.07. What is the ratio of the Consumption of fixed capital (as % of GNI) of Algeria in 2006 to that in 2011?
Keep it short and to the point. 1.03. What is the ratio of the Consumption of fixed capital (as % of GNI) of Bahrain in 2006 to that in 2011?
Your answer should be very brief. 0.96. What is the ratio of the Consumption of fixed capital (as % of GNI) of Palau in 2006 to that in 2011?
Keep it short and to the point. 1.05. What is the ratio of the Consumption of fixed capital (as % of GNI) of Algeria in 2007 to that in 2008?
Keep it short and to the point. 1.04. What is the ratio of the Consumption of fixed capital (as % of GNI) of Bahrain in 2007 to that in 2008?
Your answer should be very brief. 1.15. What is the ratio of the Consumption of fixed capital (as % of GNI) of Palau in 2007 to that in 2008?
Offer a very short reply. 1.01. What is the ratio of the Consumption of fixed capital (as % of GNI) of Algeria in 2007 to that in 2009?
Your answer should be very brief. 0.94. What is the ratio of the Consumption of fixed capital (as % of GNI) of Bahrain in 2007 to that in 2009?
Ensure brevity in your answer.  0.94. What is the ratio of the Consumption of fixed capital (as % of GNI) of Palau in 2007 to that in 2009?
Keep it short and to the point. 1.06. What is the ratio of the Consumption of fixed capital (as % of GNI) in Algeria in 2007 to that in 2010?
Your answer should be compact. 0.97. What is the ratio of the Consumption of fixed capital (as % of GNI) in Bahrain in 2007 to that in 2010?
Your answer should be compact. 0.96. What is the ratio of the Consumption of fixed capital (as % of GNI) in Palau in 2007 to that in 2010?
Offer a very short reply. 1.06. What is the ratio of the Consumption of fixed capital (as % of GNI) in Algeria in 2007 to that in 2011?
Provide a succinct answer. 1.01. What is the ratio of the Consumption of fixed capital (as % of GNI) of Bahrain in 2007 to that in 2011?
Your answer should be very brief. 0.91. What is the ratio of the Consumption of fixed capital (as % of GNI) in Palau in 2007 to that in 2011?
Provide a succinct answer. 1.04. What is the ratio of the Consumption of fixed capital (as % of GNI) of Algeria in 2008 to that in 2009?
Give a very brief answer. 0.91. What is the ratio of the Consumption of fixed capital (as % of GNI) of Bahrain in 2008 to that in 2009?
Offer a terse response. 0.82. What is the ratio of the Consumption of fixed capital (as % of GNI) in Palau in 2008 to that in 2009?
Make the answer very short. 1.04. What is the ratio of the Consumption of fixed capital (as % of GNI) of Algeria in 2008 to that in 2010?
Make the answer very short. 0.93. What is the ratio of the Consumption of fixed capital (as % of GNI) in Bahrain in 2008 to that in 2010?
Your response must be concise. 0.84. What is the ratio of the Consumption of fixed capital (as % of GNI) of Palau in 2008 to that in 2010?
Your answer should be compact. 1.04. What is the ratio of the Consumption of fixed capital (as % of GNI) in Algeria in 2008 to that in 2011?
Offer a very short reply. 0.97. What is the ratio of the Consumption of fixed capital (as % of GNI) in Bahrain in 2008 to that in 2011?
Make the answer very short. 0.8. What is the ratio of the Consumption of fixed capital (as % of GNI) in Palau in 2008 to that in 2011?
Keep it short and to the point. 1.03. What is the ratio of the Consumption of fixed capital (as % of GNI) of Algeria in 2009 to that in 2010?
Your answer should be very brief. 1.03. What is the ratio of the Consumption of fixed capital (as % of GNI) in Bahrain in 2009 to that in 2010?
Give a very brief answer. 1.02. What is the ratio of the Consumption of fixed capital (as % of GNI) of Algeria in 2009 to that in 2011?
Keep it short and to the point. 1.08. What is the ratio of the Consumption of fixed capital (as % of GNI) of Bahrain in 2009 to that in 2011?
Make the answer very short. 0.97. What is the ratio of the Consumption of fixed capital (as % of GNI) in Palau in 2009 to that in 2011?
Ensure brevity in your answer.  0.98. What is the ratio of the Consumption of fixed capital (as % of GNI) of Algeria in 2010 to that in 2011?
Ensure brevity in your answer.  1.05. What is the ratio of the Consumption of fixed capital (as % of GNI) of Bahrain in 2010 to that in 2011?
Your response must be concise. 0.95. What is the ratio of the Consumption of fixed capital (as % of GNI) of Palau in 2010 to that in 2011?
Offer a very short reply. 0.98. What is the difference between the highest and the second highest Consumption of fixed capital (as % of GNI) in Algeria?
Offer a very short reply. 0.06. What is the difference between the highest and the second highest Consumption of fixed capital (as % of GNI) of Bahrain?
Offer a terse response. 1.33. What is the difference between the highest and the second highest Consumption of fixed capital (as % of GNI) in Palau?
Your answer should be very brief. 0.15. What is the difference between the highest and the lowest Consumption of fixed capital (as % of GNI) of Algeria?
Provide a succinct answer. 0.73. What is the difference between the highest and the lowest Consumption of fixed capital (as % of GNI) of Bahrain?
Your response must be concise. 2.73. What is the difference between the highest and the lowest Consumption of fixed capital (as % of GNI) in Palau?
Provide a short and direct response. 1.09. 